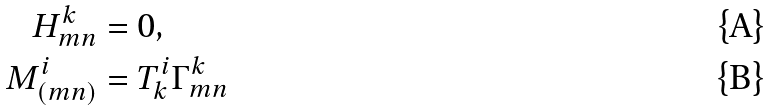Convert formula to latex. <formula><loc_0><loc_0><loc_500><loc_500>H _ { m n } ^ { k } & = 0 , \\ M _ { ( m n ) } ^ { i } & = T _ { k } ^ { i } \Gamma _ { m n } ^ { k }</formula> 